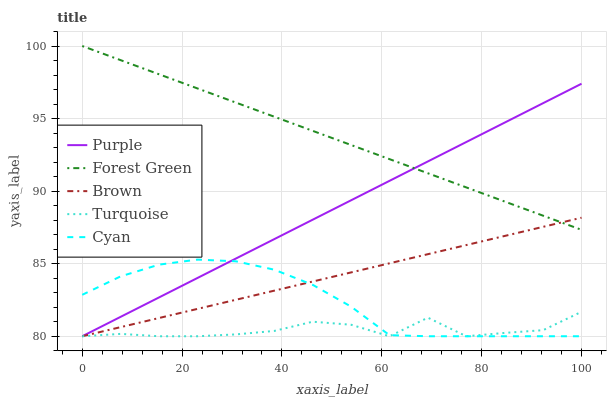Does Turquoise have the minimum area under the curve?
Answer yes or no. Yes. Does Forest Green have the maximum area under the curve?
Answer yes or no. Yes. Does Brown have the minimum area under the curve?
Answer yes or no. No. Does Brown have the maximum area under the curve?
Answer yes or no. No. Is Purple the smoothest?
Answer yes or no. Yes. Is Turquoise the roughest?
Answer yes or no. Yes. Is Brown the smoothest?
Answer yes or no. No. Is Brown the roughest?
Answer yes or no. No. Does Purple have the lowest value?
Answer yes or no. Yes. Does Forest Green have the lowest value?
Answer yes or no. No. Does Forest Green have the highest value?
Answer yes or no. Yes. Does Brown have the highest value?
Answer yes or no. No. Is Turquoise less than Forest Green?
Answer yes or no. Yes. Is Forest Green greater than Turquoise?
Answer yes or no. Yes. Does Turquoise intersect Cyan?
Answer yes or no. Yes. Is Turquoise less than Cyan?
Answer yes or no. No. Is Turquoise greater than Cyan?
Answer yes or no. No. Does Turquoise intersect Forest Green?
Answer yes or no. No. 